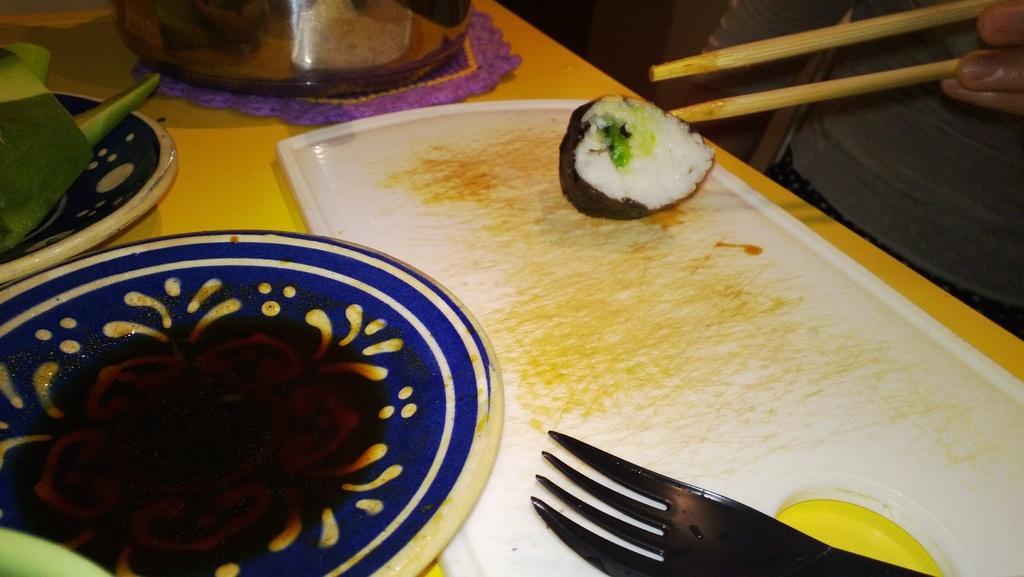What is the main object in the center of the image? There is a table in the center of the image. What items can be found on the table? On the table, there is a plate, a fork, vegetables, a cloth, and fruit. Can you describe the human visible in the image? There is a human visible on the top right of the image. What type of dirt can be seen on the floor in the image? There is no dirt visible on the floor in the image. What kind of party is being held in the image? There is no party depicted in the image; it shows a table with various items on it and a human in the top right corner. 